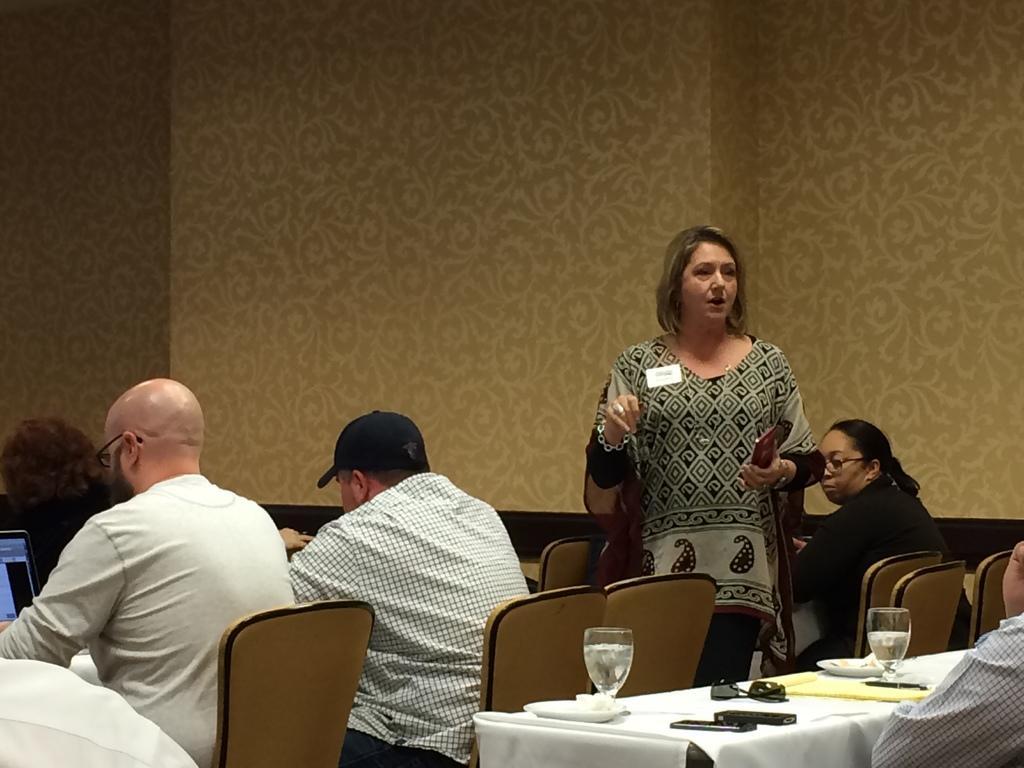Describe this image in one or two sentences. Bottom left side of the image few people are sitting on chairs. Bottom right side of the image there is a table on the table there are some glasses and papers and mobiles and pens and there is a plate. Bottom right side of the image a man is sitting. In the middle of the image a woman is standing and speaking and she is holding something in her hand. Behind her there is a woman sitting on chair. Top of the image there is a wall. 